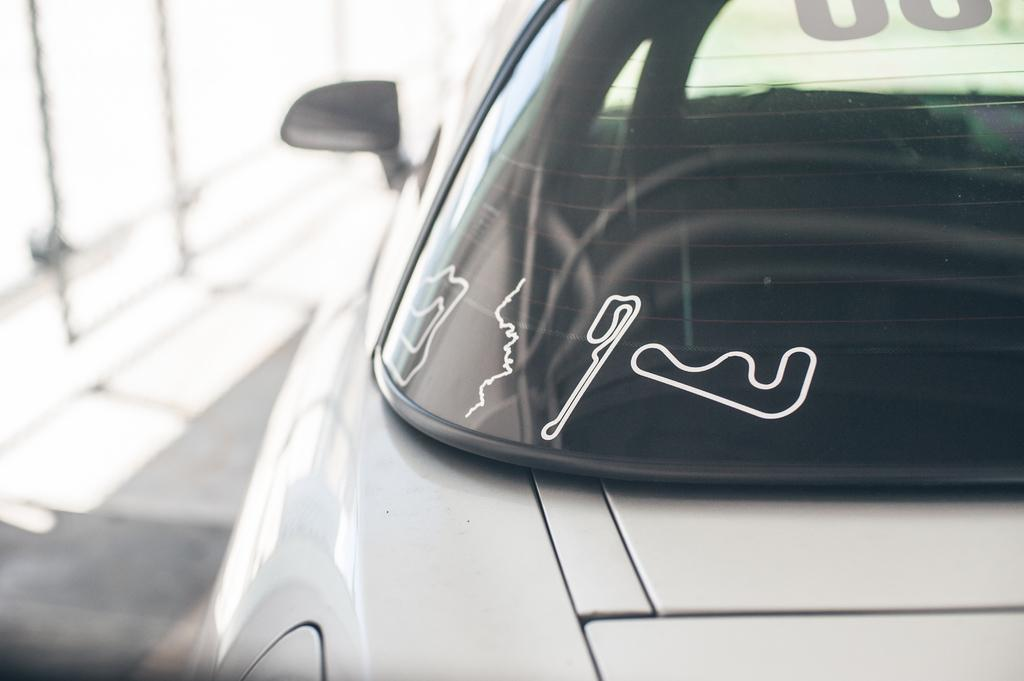What color is the vehicle in the image? The vehicle in the image is white. Are there any markings or stickers on the vehicle? Yes, there are white stickers on the windshield of the vehicle. Can you describe the quality of the image? The image is slightly blurry in the background. How many mines are present in the image? There are no mines present in the image; it features a white-colored vehicle with white stickers on the windshield. 